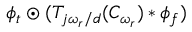<formula> <loc_0><loc_0><loc_500><loc_500>\phi _ { t } \odot ( T _ { j \omega _ { r } / d } ( C _ { \omega _ { r } } ) * \phi _ { f } )</formula> 